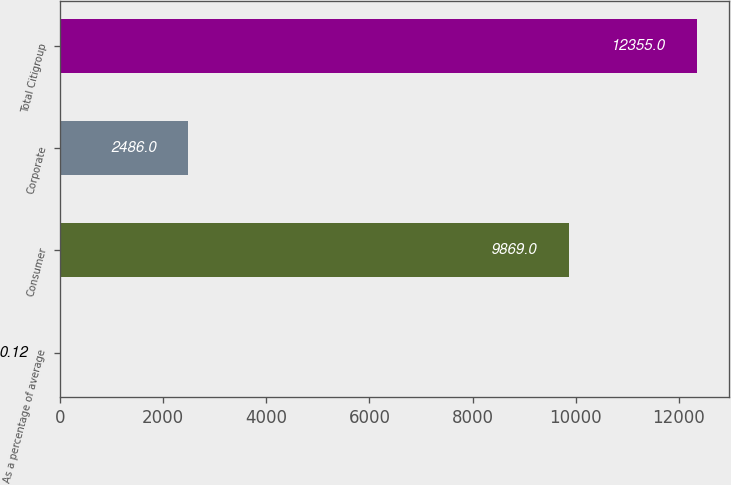Convert chart to OTSL. <chart><loc_0><loc_0><loc_500><loc_500><bar_chart><fcel>As a percentage of average<fcel>Consumer<fcel>Corporate<fcel>Total Citigroup<nl><fcel>0.12<fcel>9869<fcel>2486<fcel>12355<nl></chart> 